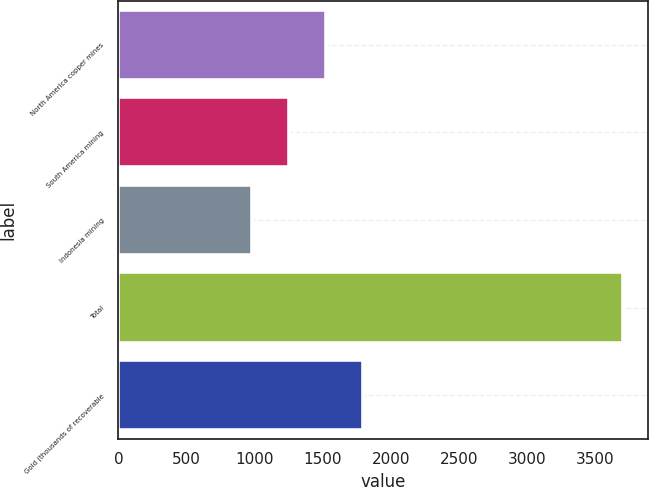<chart> <loc_0><loc_0><loc_500><loc_500><bar_chart><fcel>North America copper mines<fcel>South America mining<fcel>Indonesia mining<fcel>Total<fcel>Gold (thousands of recoverable<nl><fcel>1524.8<fcel>1252.9<fcel>981<fcel>3700<fcel>1796.7<nl></chart> 